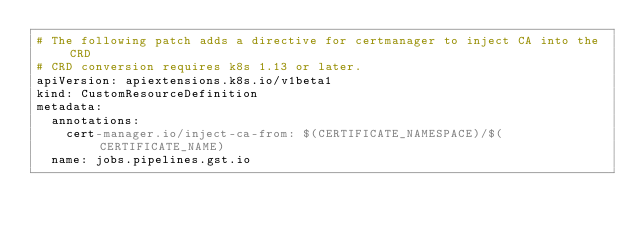Convert code to text. <code><loc_0><loc_0><loc_500><loc_500><_YAML_># The following patch adds a directive for certmanager to inject CA into the CRD
# CRD conversion requires k8s 1.13 or later.
apiVersion: apiextensions.k8s.io/v1beta1
kind: CustomResourceDefinition
metadata:
  annotations:
    cert-manager.io/inject-ca-from: $(CERTIFICATE_NAMESPACE)/$(CERTIFICATE_NAME)
  name: jobs.pipelines.gst.io
</code> 